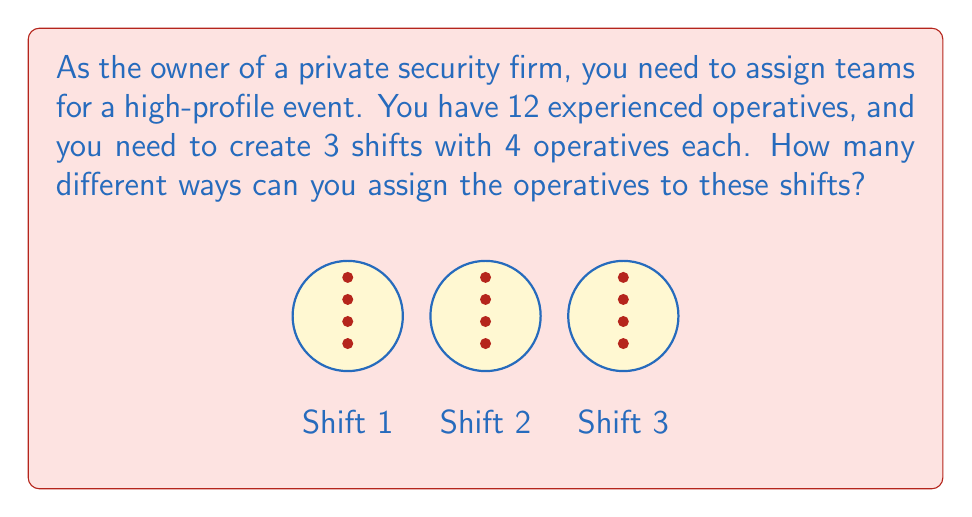Solve this math problem. Let's approach this step-by-step:

1) First, we need to choose 4 operatives for the first shift. This can be done in $\binom{12}{4}$ ways.

2) After assigning the first shift, we have 8 operatives left, and we need to choose 4 for the second shift. This can be done in $\binom{8}{4}$ ways.

3) For the last shift, we don't have a choice - the remaining 4 operatives will be assigned to it.

4) By the multiplication principle, the total number of ways to assign the operatives is:

   $$\binom{12}{4} \times \binom{8}{4}$$

5) Let's calculate these values:
   
   $\binom{12}{4} = \frac{12!}{4!(12-4)!} = \frac{12!}{4!8!} = 495$
   
   $\binom{8}{4} = \frac{8!}{4!(8-4)!} = \frac{8!}{4!4!} = 70$

6) Therefore, the total number of ways is:

   $$495 \times 70 = 34,650$$
Answer: 34,650 